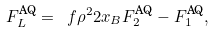Convert formula to latex. <formula><loc_0><loc_0><loc_500><loc_500>F ^ { \text {AQ} } _ { L } = \ f { \rho ^ { 2 } } { 2 x _ { B } } F ^ { \text {AQ} } _ { 2 } - F _ { 1 } ^ { \text {AQ} } ,</formula> 